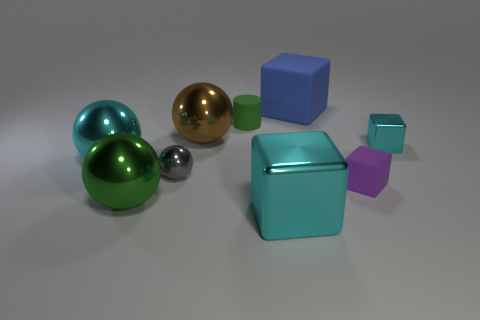What shape is the small object that is both left of the blue matte thing and in front of the large brown object? The small object located to the left of the blue matte cube and in front of the large brown object is a sphere. It has a reflective surface, which suggests it's likely made of a metallic material. 